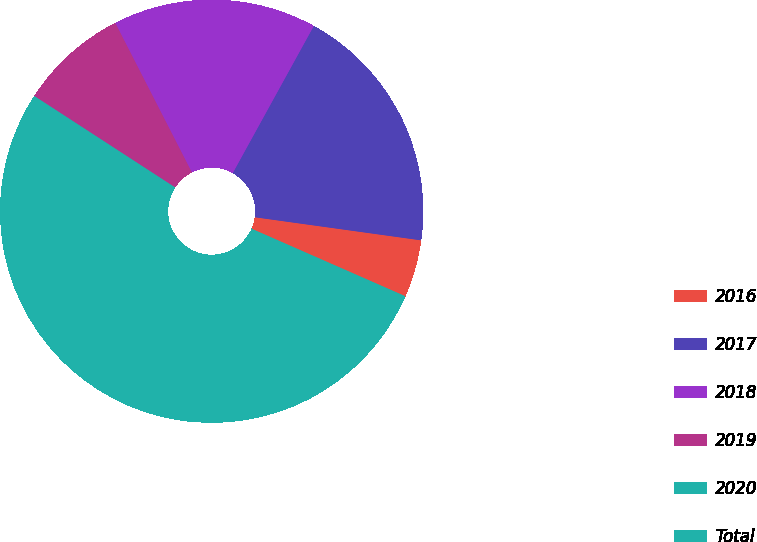Convert chart. <chart><loc_0><loc_0><loc_500><loc_500><pie_chart><fcel>2016<fcel>2017<fcel>2018<fcel>2019<fcel>2020<fcel>Total<nl><fcel>4.39%<fcel>19.18%<fcel>15.55%<fcel>8.3%<fcel>11.92%<fcel>40.66%<nl></chart> 